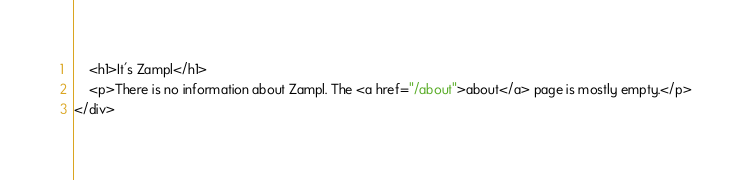Convert code to text. <code><loc_0><loc_0><loc_500><loc_500><_HTML_>    <h1>It's Zampl</h1>
    <p>There is no information about Zampl. The <a href="/about">about</a> page is mostly empty.</p>
</div>
</code> 